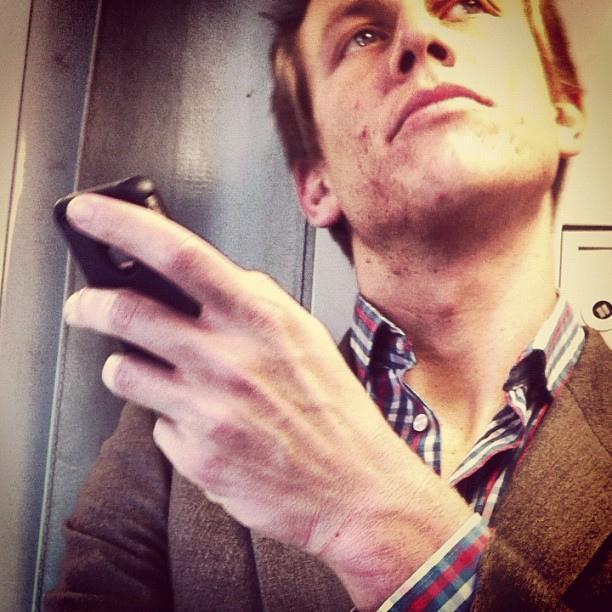How many airplanes are there?
Give a very brief answer. 0. 